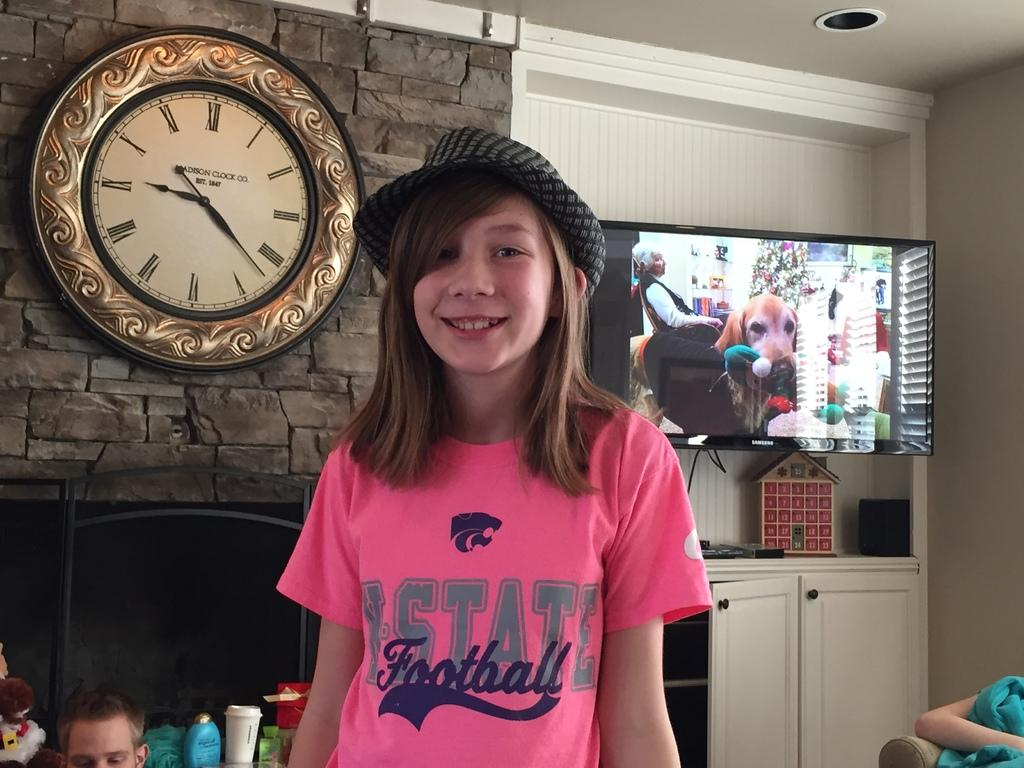<image>
Share a concise interpretation of the image provided. Girl wearing a hat and a pink shirt that says "State Football". 